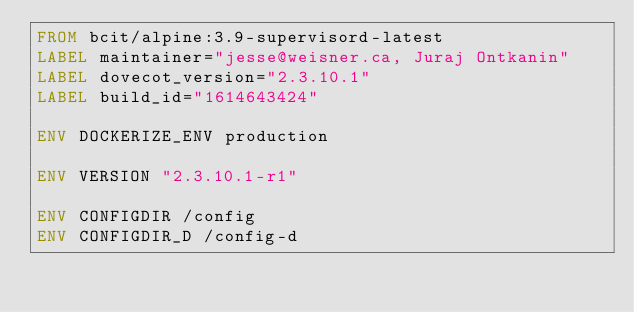<code> <loc_0><loc_0><loc_500><loc_500><_Dockerfile_>FROM bcit/alpine:3.9-supervisord-latest
LABEL maintainer="jesse@weisner.ca, Juraj Ontkanin"
LABEL dovecot_version="2.3.10.1"
LABEL build_id="1614643424"

ENV DOCKERIZE_ENV production

ENV VERSION "2.3.10.1-r1"

ENV CONFIGDIR /config
ENV CONFIGDIR_D /config-d</code> 